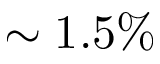Convert formula to latex. <formula><loc_0><loc_0><loc_500><loc_500>\sim 1 . 5 \%</formula> 